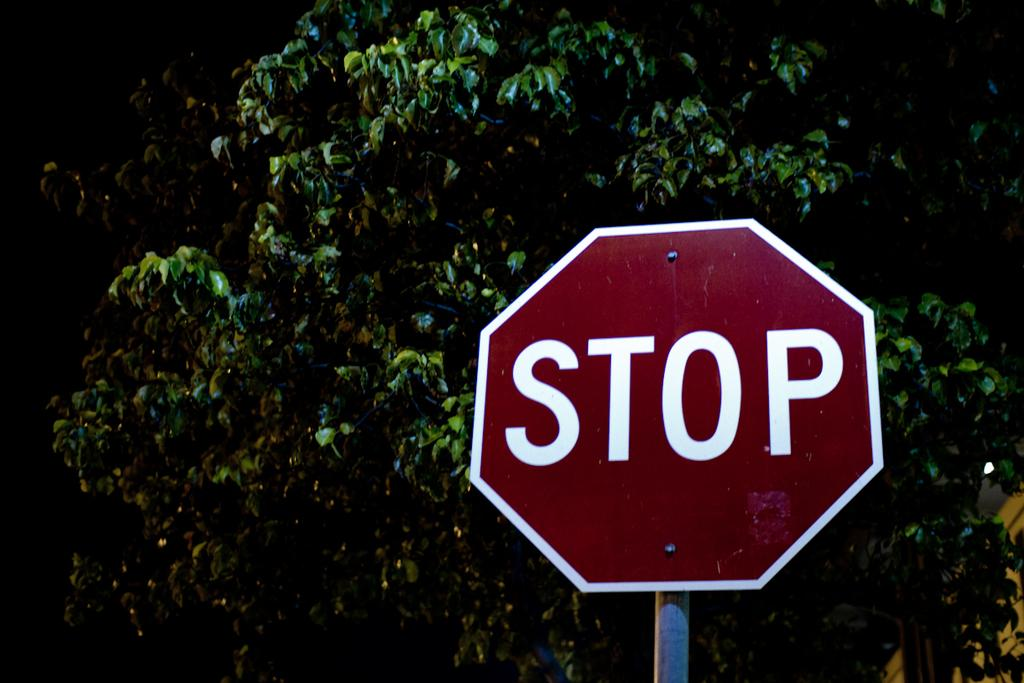What is present on the sign board in the image? There is text on the sign board in the image. What can be seen in the background of the image? There are trees in the background of the image. What type of chin is visible on the cart in the image? There is no cart or chin present in the image. 